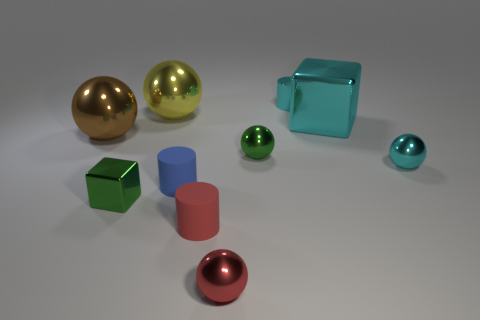Subtract all small cyan balls. How many balls are left? 4 Subtract all cyan spheres. How many spheres are left? 4 Subtract all gray balls. Subtract all red cylinders. How many balls are left? 5 Subtract all cylinders. How many objects are left? 7 Add 4 tiny blue metal spheres. How many tiny blue metal spheres exist? 4 Subtract 0 red cubes. How many objects are left? 10 Subtract all tiny matte balls. Subtract all brown shiny balls. How many objects are left? 9 Add 2 small shiny objects. How many small shiny objects are left? 7 